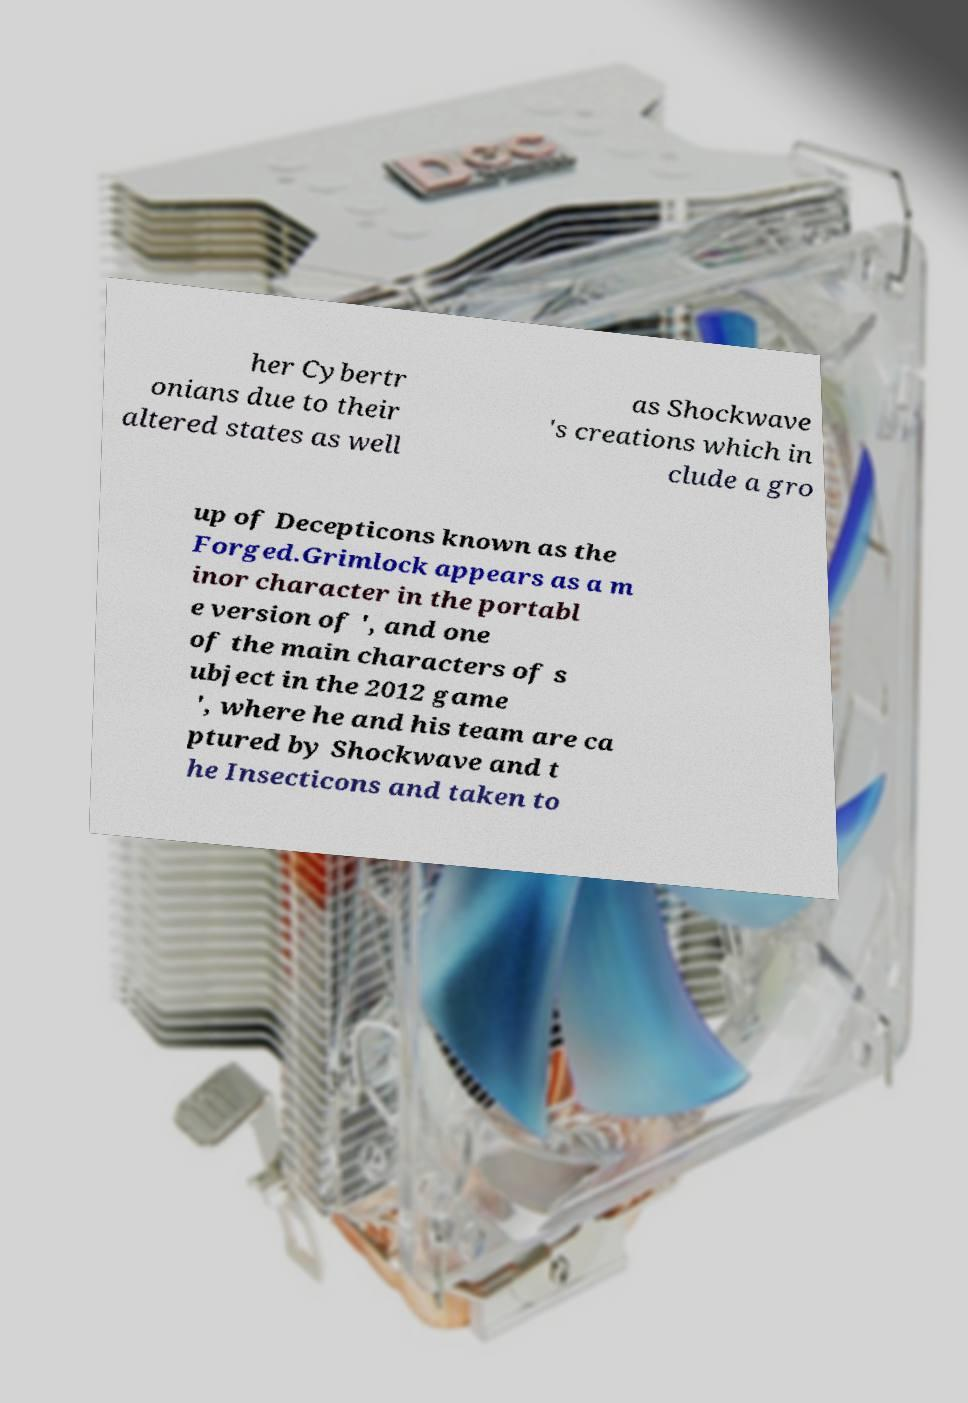Please read and relay the text visible in this image. What does it say? her Cybertr onians due to their altered states as well as Shockwave 's creations which in clude a gro up of Decepticons known as the Forged.Grimlock appears as a m inor character in the portabl e version of ', and one of the main characters of s ubject in the 2012 game ', where he and his team are ca ptured by Shockwave and t he Insecticons and taken to 